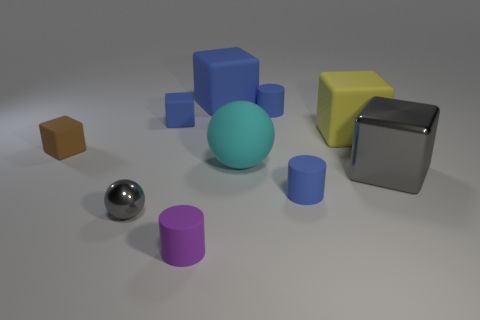There is a sphere that is right of the blue block on the right side of the purple matte thing; what size is it?
Offer a very short reply. Large. What material is the blue thing that is behind the big yellow thing and right of the big blue object?
Give a very brief answer. Rubber. What color is the matte sphere?
Ensure brevity in your answer.  Cyan. Is there any other thing that has the same material as the yellow object?
Offer a terse response. Yes. The shiny object that is to the left of the tiny purple thing has what shape?
Provide a short and direct response. Sphere. Are there any large cyan balls that are behind the tiny cylinder behind the small brown matte thing behind the large cyan object?
Provide a succinct answer. No. Are there any small gray rubber cubes?
Offer a very short reply. No. Is the material of the tiny brown object in front of the small blue cube the same as the blue cylinder behind the brown cube?
Your response must be concise. Yes. There is a blue cube on the right side of the matte cylinder in front of the gray object that is left of the tiny purple object; how big is it?
Provide a succinct answer. Large. How many big cyan things are made of the same material as the yellow cube?
Provide a succinct answer. 1. 